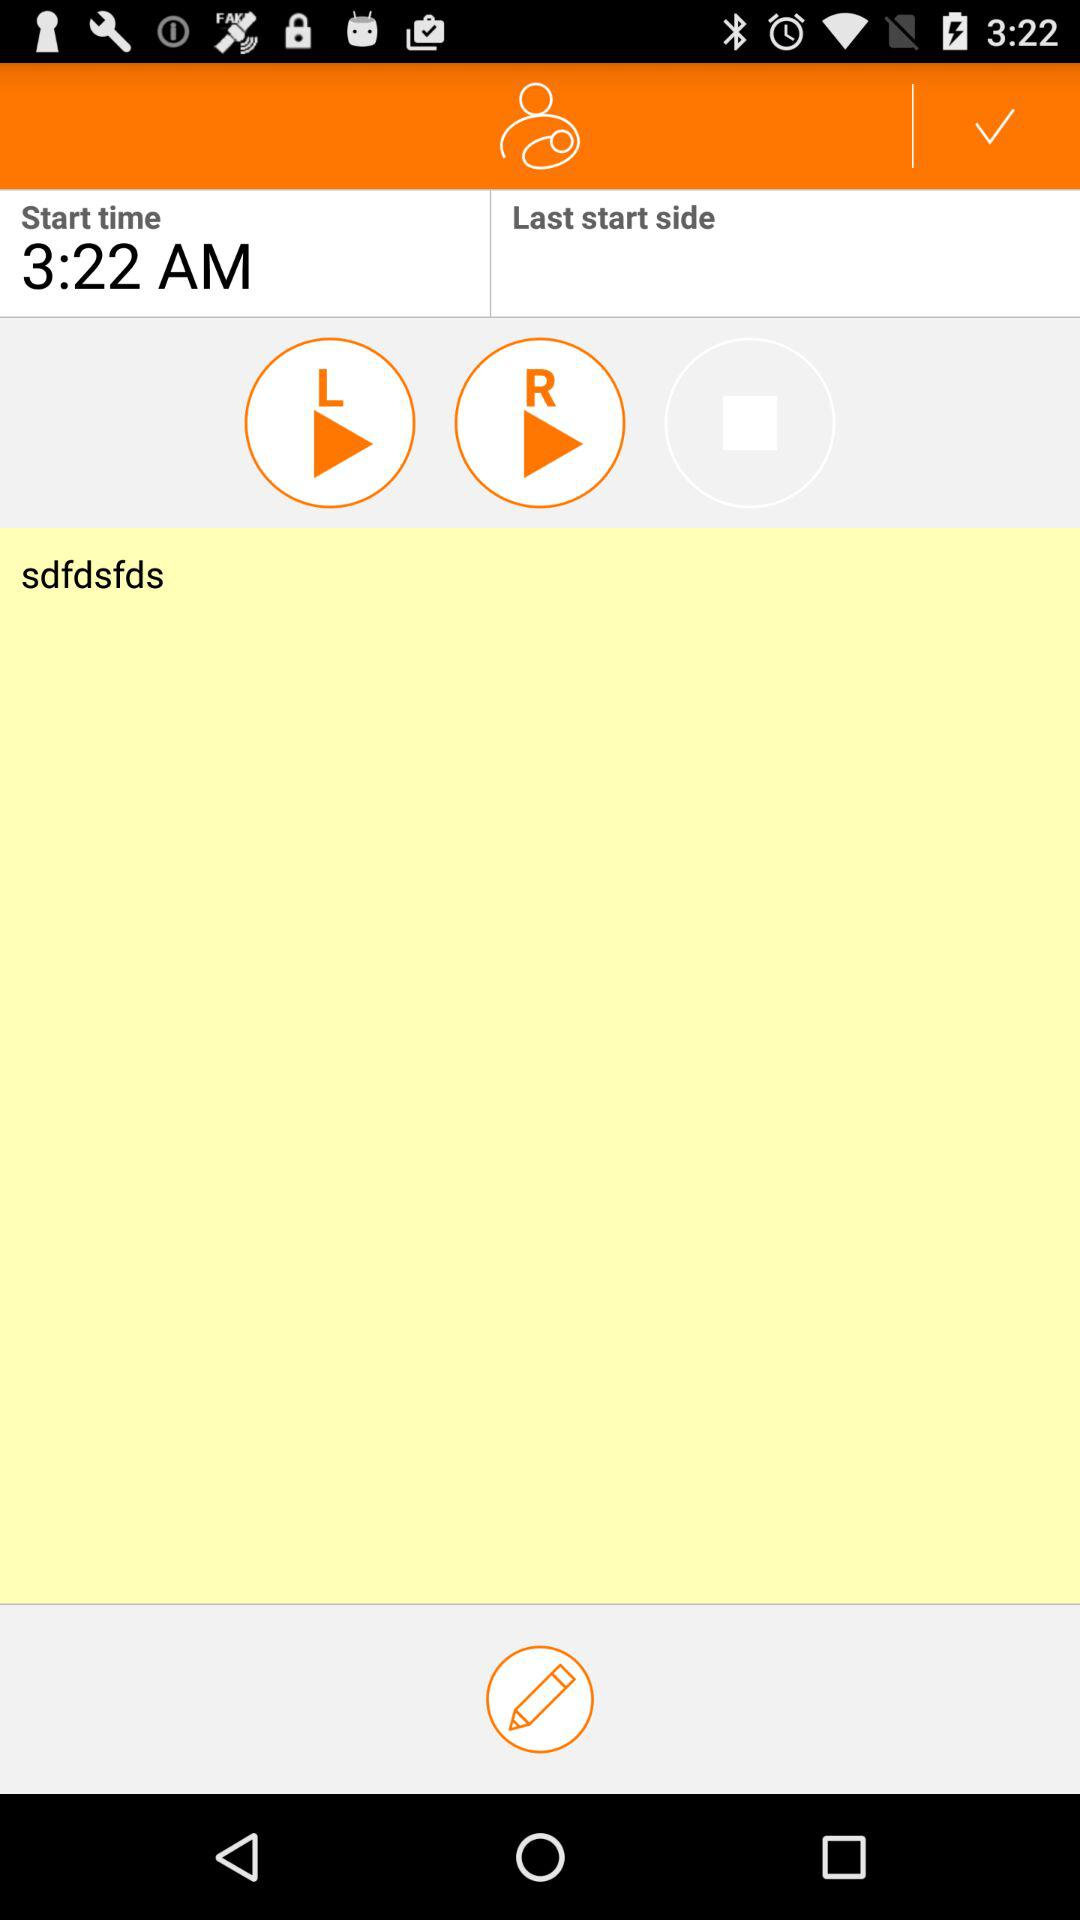What is the start time? The start time is 3:22 AM. 